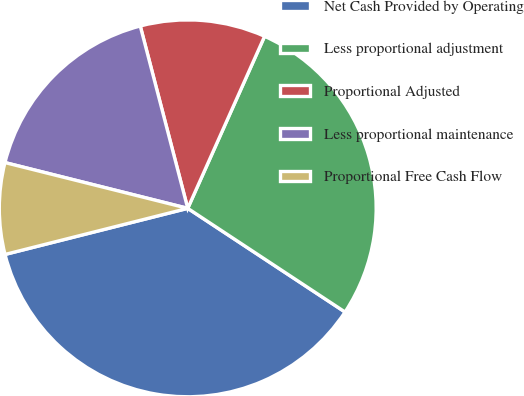Convert chart. <chart><loc_0><loc_0><loc_500><loc_500><pie_chart><fcel>Net Cash Provided by Operating<fcel>Less proportional adjustment<fcel>Proportional Adjusted<fcel>Less proportional maintenance<fcel>Proportional Free Cash Flow<nl><fcel>36.79%<fcel>27.59%<fcel>10.74%<fcel>17.04%<fcel>7.84%<nl></chart> 